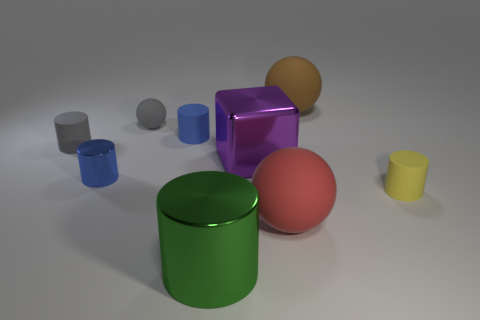What is the shape of the matte object that is the same color as the small ball?
Offer a very short reply. Cylinder. What number of balls are right of the big matte thing that is in front of the small yellow rubber cylinder behind the large red sphere?
Offer a terse response. 1. There is a object to the right of the brown rubber sphere to the right of the green thing; what size is it?
Provide a short and direct response. Small. There is a purple thing that is made of the same material as the green cylinder; what is its size?
Offer a terse response. Large. There is a thing that is on the right side of the green metallic cylinder and behind the big purple block; what shape is it?
Make the answer very short. Sphere. Are there an equal number of small spheres that are right of the large purple shiny thing and large green metallic spheres?
Make the answer very short. Yes. What number of things are either green cylinders or large matte things in front of the tiny yellow object?
Give a very brief answer. 2. Is there another big brown matte thing that has the same shape as the brown matte object?
Provide a short and direct response. No. Is the number of small blue metal cylinders on the right side of the brown sphere the same as the number of green cylinders that are on the right side of the big red rubber object?
Offer a very short reply. Yes. Are there any other things that have the same size as the brown matte object?
Your answer should be compact. Yes. 